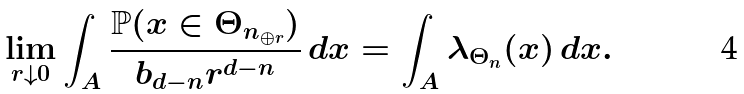Convert formula to latex. <formula><loc_0><loc_0><loc_500><loc_500>\lim _ { r \downarrow 0 } \int _ { A } \frac { \mathbb { P } ( x \in \Theta _ { n _ { \oplus r } } ) } { b _ { d - n } r ^ { d - n } } \, d x = \int _ { A } \lambda _ { \Theta _ { n } } ( x ) \, d x .</formula> 